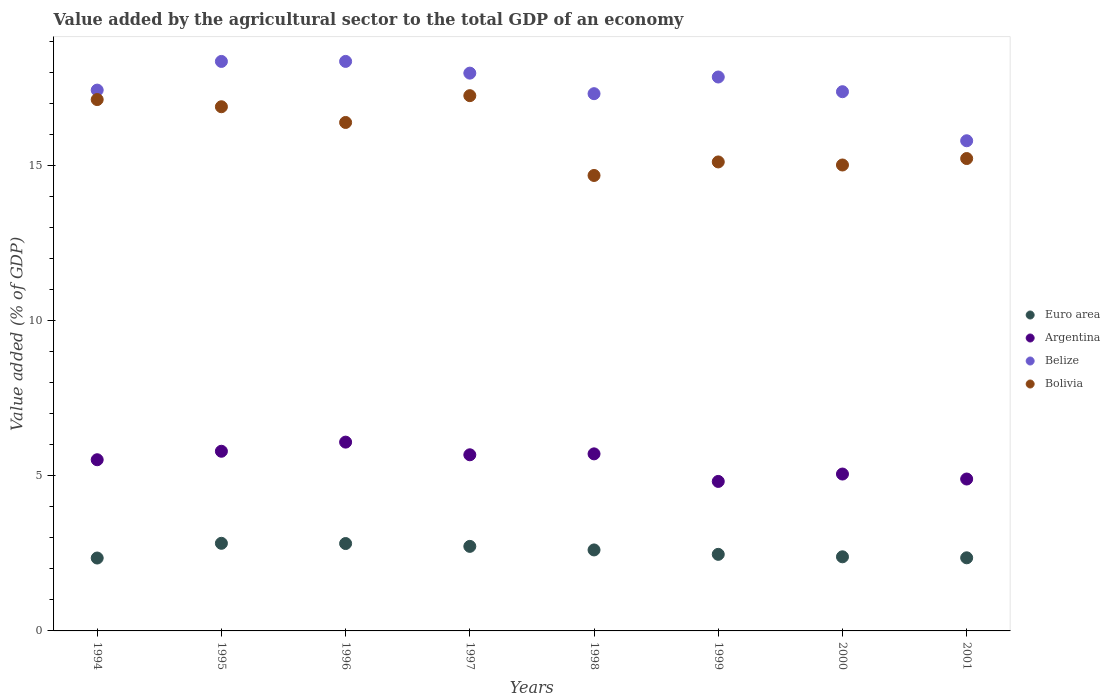How many different coloured dotlines are there?
Your answer should be very brief. 4. What is the value added by the agricultural sector to the total GDP in Argentina in 1994?
Your response must be concise. 5.51. Across all years, what is the maximum value added by the agricultural sector to the total GDP in Bolivia?
Keep it short and to the point. 17.24. Across all years, what is the minimum value added by the agricultural sector to the total GDP in Belize?
Make the answer very short. 15.79. In which year was the value added by the agricultural sector to the total GDP in Euro area minimum?
Offer a very short reply. 1994. What is the total value added by the agricultural sector to the total GDP in Euro area in the graph?
Provide a succinct answer. 20.53. What is the difference between the value added by the agricultural sector to the total GDP in Bolivia in 1994 and that in 2001?
Ensure brevity in your answer.  1.9. What is the difference between the value added by the agricultural sector to the total GDP in Euro area in 1995 and the value added by the agricultural sector to the total GDP in Bolivia in 1999?
Give a very brief answer. -12.28. What is the average value added by the agricultural sector to the total GDP in Argentina per year?
Your answer should be very brief. 5.44. In the year 1997, what is the difference between the value added by the agricultural sector to the total GDP in Euro area and value added by the agricultural sector to the total GDP in Belize?
Make the answer very short. -15.24. What is the ratio of the value added by the agricultural sector to the total GDP in Euro area in 1995 to that in 2000?
Your answer should be very brief. 1.18. Is the value added by the agricultural sector to the total GDP in Belize in 1997 less than that in 1999?
Keep it short and to the point. No. What is the difference between the highest and the second highest value added by the agricultural sector to the total GDP in Euro area?
Your response must be concise. 0.01. What is the difference between the highest and the lowest value added by the agricultural sector to the total GDP in Euro area?
Offer a terse response. 0.47. In how many years, is the value added by the agricultural sector to the total GDP in Bolivia greater than the average value added by the agricultural sector to the total GDP in Bolivia taken over all years?
Offer a very short reply. 4. Is it the case that in every year, the sum of the value added by the agricultural sector to the total GDP in Argentina and value added by the agricultural sector to the total GDP in Bolivia  is greater than the sum of value added by the agricultural sector to the total GDP in Belize and value added by the agricultural sector to the total GDP in Euro area?
Give a very brief answer. No. Is it the case that in every year, the sum of the value added by the agricultural sector to the total GDP in Belize and value added by the agricultural sector to the total GDP in Argentina  is greater than the value added by the agricultural sector to the total GDP in Euro area?
Keep it short and to the point. Yes. Is the value added by the agricultural sector to the total GDP in Euro area strictly greater than the value added by the agricultural sector to the total GDP in Argentina over the years?
Your answer should be compact. No. Is the value added by the agricultural sector to the total GDP in Bolivia strictly less than the value added by the agricultural sector to the total GDP in Euro area over the years?
Offer a terse response. No. How many dotlines are there?
Your response must be concise. 4. Are the values on the major ticks of Y-axis written in scientific E-notation?
Provide a succinct answer. No. Does the graph contain any zero values?
Offer a very short reply. No. Does the graph contain grids?
Give a very brief answer. No. How are the legend labels stacked?
Your answer should be very brief. Vertical. What is the title of the graph?
Offer a terse response. Value added by the agricultural sector to the total GDP of an economy. Does "Syrian Arab Republic" appear as one of the legend labels in the graph?
Keep it short and to the point. No. What is the label or title of the Y-axis?
Your answer should be very brief. Value added (% of GDP). What is the Value added (% of GDP) in Euro area in 1994?
Give a very brief answer. 2.35. What is the Value added (% of GDP) of Argentina in 1994?
Offer a very short reply. 5.51. What is the Value added (% of GDP) in Belize in 1994?
Provide a short and direct response. 17.42. What is the Value added (% of GDP) of Bolivia in 1994?
Offer a terse response. 17.11. What is the Value added (% of GDP) of Euro area in 1995?
Offer a very short reply. 2.82. What is the Value added (% of GDP) of Argentina in 1995?
Your answer should be very brief. 5.79. What is the Value added (% of GDP) in Belize in 1995?
Offer a terse response. 18.34. What is the Value added (% of GDP) of Bolivia in 1995?
Ensure brevity in your answer.  16.88. What is the Value added (% of GDP) in Euro area in 1996?
Ensure brevity in your answer.  2.81. What is the Value added (% of GDP) in Argentina in 1996?
Make the answer very short. 6.08. What is the Value added (% of GDP) of Belize in 1996?
Ensure brevity in your answer.  18.34. What is the Value added (% of GDP) in Bolivia in 1996?
Provide a short and direct response. 16.38. What is the Value added (% of GDP) of Euro area in 1997?
Your answer should be compact. 2.72. What is the Value added (% of GDP) in Argentina in 1997?
Offer a very short reply. 5.67. What is the Value added (% of GDP) of Belize in 1997?
Give a very brief answer. 17.97. What is the Value added (% of GDP) of Bolivia in 1997?
Provide a succinct answer. 17.24. What is the Value added (% of GDP) of Euro area in 1998?
Your answer should be compact. 2.61. What is the Value added (% of GDP) of Argentina in 1998?
Your answer should be compact. 5.7. What is the Value added (% of GDP) in Belize in 1998?
Make the answer very short. 17.3. What is the Value added (% of GDP) of Bolivia in 1998?
Make the answer very short. 14.67. What is the Value added (% of GDP) of Euro area in 1999?
Your answer should be compact. 2.47. What is the Value added (% of GDP) in Argentina in 1999?
Provide a short and direct response. 4.82. What is the Value added (% of GDP) in Belize in 1999?
Keep it short and to the point. 17.84. What is the Value added (% of GDP) of Bolivia in 1999?
Offer a very short reply. 15.11. What is the Value added (% of GDP) of Euro area in 2000?
Your answer should be compact. 2.39. What is the Value added (% of GDP) of Argentina in 2000?
Make the answer very short. 5.05. What is the Value added (% of GDP) of Belize in 2000?
Make the answer very short. 17.37. What is the Value added (% of GDP) in Bolivia in 2000?
Your response must be concise. 15.01. What is the Value added (% of GDP) of Euro area in 2001?
Your response must be concise. 2.36. What is the Value added (% of GDP) of Argentina in 2001?
Your answer should be very brief. 4.89. What is the Value added (% of GDP) in Belize in 2001?
Offer a terse response. 15.79. What is the Value added (% of GDP) of Bolivia in 2001?
Provide a short and direct response. 15.22. Across all years, what is the maximum Value added (% of GDP) of Euro area?
Offer a very short reply. 2.82. Across all years, what is the maximum Value added (% of GDP) of Argentina?
Your answer should be compact. 6.08. Across all years, what is the maximum Value added (% of GDP) of Belize?
Your answer should be compact. 18.34. Across all years, what is the maximum Value added (% of GDP) of Bolivia?
Provide a short and direct response. 17.24. Across all years, what is the minimum Value added (% of GDP) in Euro area?
Make the answer very short. 2.35. Across all years, what is the minimum Value added (% of GDP) in Argentina?
Make the answer very short. 4.82. Across all years, what is the minimum Value added (% of GDP) in Belize?
Ensure brevity in your answer.  15.79. Across all years, what is the minimum Value added (% of GDP) of Bolivia?
Provide a short and direct response. 14.67. What is the total Value added (% of GDP) in Euro area in the graph?
Provide a succinct answer. 20.53. What is the total Value added (% of GDP) in Argentina in the graph?
Provide a succinct answer. 43.52. What is the total Value added (% of GDP) of Belize in the graph?
Provide a succinct answer. 140.38. What is the total Value added (% of GDP) in Bolivia in the graph?
Offer a terse response. 127.62. What is the difference between the Value added (% of GDP) of Euro area in 1994 and that in 1995?
Offer a very short reply. -0.47. What is the difference between the Value added (% of GDP) in Argentina in 1994 and that in 1995?
Your answer should be very brief. -0.27. What is the difference between the Value added (% of GDP) of Belize in 1994 and that in 1995?
Give a very brief answer. -0.92. What is the difference between the Value added (% of GDP) of Bolivia in 1994 and that in 1995?
Ensure brevity in your answer.  0.23. What is the difference between the Value added (% of GDP) of Euro area in 1994 and that in 1996?
Keep it short and to the point. -0.47. What is the difference between the Value added (% of GDP) of Argentina in 1994 and that in 1996?
Your answer should be very brief. -0.57. What is the difference between the Value added (% of GDP) in Belize in 1994 and that in 1996?
Provide a short and direct response. -0.92. What is the difference between the Value added (% of GDP) of Bolivia in 1994 and that in 1996?
Give a very brief answer. 0.74. What is the difference between the Value added (% of GDP) of Euro area in 1994 and that in 1997?
Make the answer very short. -0.38. What is the difference between the Value added (% of GDP) of Argentina in 1994 and that in 1997?
Ensure brevity in your answer.  -0.16. What is the difference between the Value added (% of GDP) in Belize in 1994 and that in 1997?
Provide a succinct answer. -0.55. What is the difference between the Value added (% of GDP) of Bolivia in 1994 and that in 1997?
Provide a succinct answer. -0.13. What is the difference between the Value added (% of GDP) of Euro area in 1994 and that in 1998?
Ensure brevity in your answer.  -0.26. What is the difference between the Value added (% of GDP) in Argentina in 1994 and that in 1998?
Provide a succinct answer. -0.19. What is the difference between the Value added (% of GDP) in Belize in 1994 and that in 1998?
Offer a very short reply. 0.12. What is the difference between the Value added (% of GDP) in Bolivia in 1994 and that in 1998?
Keep it short and to the point. 2.44. What is the difference between the Value added (% of GDP) in Euro area in 1994 and that in 1999?
Your answer should be compact. -0.12. What is the difference between the Value added (% of GDP) of Argentina in 1994 and that in 1999?
Your answer should be compact. 0.7. What is the difference between the Value added (% of GDP) in Belize in 1994 and that in 1999?
Provide a short and direct response. -0.42. What is the difference between the Value added (% of GDP) in Bolivia in 1994 and that in 1999?
Your response must be concise. 2.01. What is the difference between the Value added (% of GDP) of Euro area in 1994 and that in 2000?
Make the answer very short. -0.04. What is the difference between the Value added (% of GDP) in Argentina in 1994 and that in 2000?
Your answer should be compact. 0.46. What is the difference between the Value added (% of GDP) in Belize in 1994 and that in 2000?
Your response must be concise. 0.05. What is the difference between the Value added (% of GDP) in Bolivia in 1994 and that in 2000?
Provide a succinct answer. 2.11. What is the difference between the Value added (% of GDP) in Euro area in 1994 and that in 2001?
Keep it short and to the point. -0.01. What is the difference between the Value added (% of GDP) of Argentina in 1994 and that in 2001?
Make the answer very short. 0.62. What is the difference between the Value added (% of GDP) of Belize in 1994 and that in 2001?
Your answer should be very brief. 1.63. What is the difference between the Value added (% of GDP) of Bolivia in 1994 and that in 2001?
Your answer should be compact. 1.9. What is the difference between the Value added (% of GDP) of Euro area in 1995 and that in 1996?
Keep it short and to the point. 0.01. What is the difference between the Value added (% of GDP) in Argentina in 1995 and that in 1996?
Offer a terse response. -0.29. What is the difference between the Value added (% of GDP) of Belize in 1995 and that in 1996?
Provide a short and direct response. -0. What is the difference between the Value added (% of GDP) in Bolivia in 1995 and that in 1996?
Provide a short and direct response. 0.51. What is the difference between the Value added (% of GDP) of Euro area in 1995 and that in 1997?
Your answer should be very brief. 0.1. What is the difference between the Value added (% of GDP) in Argentina in 1995 and that in 1997?
Make the answer very short. 0.11. What is the difference between the Value added (% of GDP) of Belize in 1995 and that in 1997?
Offer a very short reply. 0.38. What is the difference between the Value added (% of GDP) in Bolivia in 1995 and that in 1997?
Offer a terse response. -0.36. What is the difference between the Value added (% of GDP) in Euro area in 1995 and that in 1998?
Provide a succinct answer. 0.21. What is the difference between the Value added (% of GDP) in Argentina in 1995 and that in 1998?
Provide a short and direct response. 0.08. What is the difference between the Value added (% of GDP) of Belize in 1995 and that in 1998?
Provide a short and direct response. 1.04. What is the difference between the Value added (% of GDP) of Bolivia in 1995 and that in 1998?
Your answer should be very brief. 2.21. What is the difference between the Value added (% of GDP) of Euro area in 1995 and that in 1999?
Provide a short and direct response. 0.36. What is the difference between the Value added (% of GDP) of Argentina in 1995 and that in 1999?
Your answer should be very brief. 0.97. What is the difference between the Value added (% of GDP) of Belize in 1995 and that in 1999?
Make the answer very short. 0.5. What is the difference between the Value added (% of GDP) in Bolivia in 1995 and that in 1999?
Give a very brief answer. 1.78. What is the difference between the Value added (% of GDP) in Euro area in 1995 and that in 2000?
Your answer should be very brief. 0.43. What is the difference between the Value added (% of GDP) of Argentina in 1995 and that in 2000?
Make the answer very short. 0.73. What is the difference between the Value added (% of GDP) of Belize in 1995 and that in 2000?
Offer a very short reply. 0.98. What is the difference between the Value added (% of GDP) of Bolivia in 1995 and that in 2000?
Your answer should be very brief. 1.88. What is the difference between the Value added (% of GDP) of Euro area in 1995 and that in 2001?
Offer a very short reply. 0.47. What is the difference between the Value added (% of GDP) in Argentina in 1995 and that in 2001?
Offer a terse response. 0.89. What is the difference between the Value added (% of GDP) in Belize in 1995 and that in 2001?
Your response must be concise. 2.56. What is the difference between the Value added (% of GDP) in Bolivia in 1995 and that in 2001?
Provide a succinct answer. 1.67. What is the difference between the Value added (% of GDP) in Euro area in 1996 and that in 1997?
Your response must be concise. 0.09. What is the difference between the Value added (% of GDP) of Argentina in 1996 and that in 1997?
Give a very brief answer. 0.41. What is the difference between the Value added (% of GDP) of Belize in 1996 and that in 1997?
Provide a short and direct response. 0.38. What is the difference between the Value added (% of GDP) in Bolivia in 1996 and that in 1997?
Keep it short and to the point. -0.86. What is the difference between the Value added (% of GDP) in Euro area in 1996 and that in 1998?
Offer a very short reply. 0.21. What is the difference between the Value added (% of GDP) in Argentina in 1996 and that in 1998?
Make the answer very short. 0.38. What is the difference between the Value added (% of GDP) in Belize in 1996 and that in 1998?
Your answer should be compact. 1.04. What is the difference between the Value added (% of GDP) in Bolivia in 1996 and that in 1998?
Your answer should be compact. 1.71. What is the difference between the Value added (% of GDP) in Euro area in 1996 and that in 1999?
Keep it short and to the point. 0.35. What is the difference between the Value added (% of GDP) of Argentina in 1996 and that in 1999?
Your answer should be compact. 1.27. What is the difference between the Value added (% of GDP) of Belize in 1996 and that in 1999?
Ensure brevity in your answer.  0.5. What is the difference between the Value added (% of GDP) in Bolivia in 1996 and that in 1999?
Your answer should be compact. 1.27. What is the difference between the Value added (% of GDP) of Euro area in 1996 and that in 2000?
Keep it short and to the point. 0.43. What is the difference between the Value added (% of GDP) of Argentina in 1996 and that in 2000?
Give a very brief answer. 1.03. What is the difference between the Value added (% of GDP) of Bolivia in 1996 and that in 2000?
Your answer should be compact. 1.37. What is the difference between the Value added (% of GDP) in Euro area in 1996 and that in 2001?
Your answer should be very brief. 0.46. What is the difference between the Value added (% of GDP) of Argentina in 1996 and that in 2001?
Keep it short and to the point. 1.19. What is the difference between the Value added (% of GDP) of Belize in 1996 and that in 2001?
Offer a terse response. 2.56. What is the difference between the Value added (% of GDP) in Bolivia in 1996 and that in 2001?
Ensure brevity in your answer.  1.16. What is the difference between the Value added (% of GDP) in Euro area in 1997 and that in 1998?
Your response must be concise. 0.11. What is the difference between the Value added (% of GDP) of Argentina in 1997 and that in 1998?
Ensure brevity in your answer.  -0.03. What is the difference between the Value added (% of GDP) of Belize in 1997 and that in 1998?
Make the answer very short. 0.66. What is the difference between the Value added (% of GDP) in Bolivia in 1997 and that in 1998?
Provide a succinct answer. 2.57. What is the difference between the Value added (% of GDP) of Euro area in 1997 and that in 1999?
Offer a very short reply. 0.26. What is the difference between the Value added (% of GDP) in Argentina in 1997 and that in 1999?
Ensure brevity in your answer.  0.86. What is the difference between the Value added (% of GDP) of Belize in 1997 and that in 1999?
Provide a short and direct response. 0.12. What is the difference between the Value added (% of GDP) in Bolivia in 1997 and that in 1999?
Make the answer very short. 2.13. What is the difference between the Value added (% of GDP) in Euro area in 1997 and that in 2000?
Keep it short and to the point. 0.34. What is the difference between the Value added (% of GDP) of Argentina in 1997 and that in 2000?
Provide a succinct answer. 0.62. What is the difference between the Value added (% of GDP) in Belize in 1997 and that in 2000?
Offer a terse response. 0.6. What is the difference between the Value added (% of GDP) of Bolivia in 1997 and that in 2000?
Make the answer very short. 2.23. What is the difference between the Value added (% of GDP) in Euro area in 1997 and that in 2001?
Make the answer very short. 0.37. What is the difference between the Value added (% of GDP) in Argentina in 1997 and that in 2001?
Your response must be concise. 0.78. What is the difference between the Value added (% of GDP) in Belize in 1997 and that in 2001?
Offer a terse response. 2.18. What is the difference between the Value added (% of GDP) of Bolivia in 1997 and that in 2001?
Provide a succinct answer. 2.03. What is the difference between the Value added (% of GDP) of Euro area in 1998 and that in 1999?
Your response must be concise. 0.14. What is the difference between the Value added (% of GDP) of Argentina in 1998 and that in 1999?
Offer a terse response. 0.89. What is the difference between the Value added (% of GDP) of Belize in 1998 and that in 1999?
Provide a succinct answer. -0.54. What is the difference between the Value added (% of GDP) of Bolivia in 1998 and that in 1999?
Ensure brevity in your answer.  -0.44. What is the difference between the Value added (% of GDP) in Euro area in 1998 and that in 2000?
Your response must be concise. 0.22. What is the difference between the Value added (% of GDP) of Argentina in 1998 and that in 2000?
Your answer should be compact. 0.65. What is the difference between the Value added (% of GDP) of Belize in 1998 and that in 2000?
Your answer should be compact. -0.06. What is the difference between the Value added (% of GDP) in Bolivia in 1998 and that in 2000?
Provide a short and direct response. -0.34. What is the difference between the Value added (% of GDP) in Euro area in 1998 and that in 2001?
Give a very brief answer. 0.25. What is the difference between the Value added (% of GDP) of Argentina in 1998 and that in 2001?
Give a very brief answer. 0.81. What is the difference between the Value added (% of GDP) of Belize in 1998 and that in 2001?
Provide a short and direct response. 1.52. What is the difference between the Value added (% of GDP) of Bolivia in 1998 and that in 2001?
Offer a very short reply. -0.55. What is the difference between the Value added (% of GDP) of Euro area in 1999 and that in 2000?
Ensure brevity in your answer.  0.08. What is the difference between the Value added (% of GDP) in Argentina in 1999 and that in 2000?
Give a very brief answer. -0.24. What is the difference between the Value added (% of GDP) in Belize in 1999 and that in 2000?
Your answer should be compact. 0.47. What is the difference between the Value added (% of GDP) in Bolivia in 1999 and that in 2000?
Give a very brief answer. 0.1. What is the difference between the Value added (% of GDP) in Euro area in 1999 and that in 2001?
Your answer should be very brief. 0.11. What is the difference between the Value added (% of GDP) of Argentina in 1999 and that in 2001?
Your answer should be very brief. -0.08. What is the difference between the Value added (% of GDP) of Belize in 1999 and that in 2001?
Offer a terse response. 2.05. What is the difference between the Value added (% of GDP) in Bolivia in 1999 and that in 2001?
Give a very brief answer. -0.11. What is the difference between the Value added (% of GDP) of Euro area in 2000 and that in 2001?
Give a very brief answer. 0.03. What is the difference between the Value added (% of GDP) of Argentina in 2000 and that in 2001?
Provide a succinct answer. 0.16. What is the difference between the Value added (% of GDP) in Belize in 2000 and that in 2001?
Give a very brief answer. 1.58. What is the difference between the Value added (% of GDP) in Bolivia in 2000 and that in 2001?
Your response must be concise. -0.21. What is the difference between the Value added (% of GDP) of Euro area in 1994 and the Value added (% of GDP) of Argentina in 1995?
Keep it short and to the point. -3.44. What is the difference between the Value added (% of GDP) of Euro area in 1994 and the Value added (% of GDP) of Belize in 1995?
Provide a short and direct response. -16. What is the difference between the Value added (% of GDP) in Euro area in 1994 and the Value added (% of GDP) in Bolivia in 1995?
Make the answer very short. -14.54. What is the difference between the Value added (% of GDP) in Argentina in 1994 and the Value added (% of GDP) in Belize in 1995?
Keep it short and to the point. -12.83. What is the difference between the Value added (% of GDP) of Argentina in 1994 and the Value added (% of GDP) of Bolivia in 1995?
Your response must be concise. -11.37. What is the difference between the Value added (% of GDP) in Belize in 1994 and the Value added (% of GDP) in Bolivia in 1995?
Make the answer very short. 0.54. What is the difference between the Value added (% of GDP) in Euro area in 1994 and the Value added (% of GDP) in Argentina in 1996?
Your answer should be compact. -3.73. What is the difference between the Value added (% of GDP) in Euro area in 1994 and the Value added (% of GDP) in Belize in 1996?
Offer a very short reply. -16. What is the difference between the Value added (% of GDP) in Euro area in 1994 and the Value added (% of GDP) in Bolivia in 1996?
Your response must be concise. -14.03. What is the difference between the Value added (% of GDP) of Argentina in 1994 and the Value added (% of GDP) of Belize in 1996?
Give a very brief answer. -12.83. What is the difference between the Value added (% of GDP) of Argentina in 1994 and the Value added (% of GDP) of Bolivia in 1996?
Offer a very short reply. -10.86. What is the difference between the Value added (% of GDP) of Belize in 1994 and the Value added (% of GDP) of Bolivia in 1996?
Give a very brief answer. 1.04. What is the difference between the Value added (% of GDP) in Euro area in 1994 and the Value added (% of GDP) in Argentina in 1997?
Provide a succinct answer. -3.33. What is the difference between the Value added (% of GDP) in Euro area in 1994 and the Value added (% of GDP) in Belize in 1997?
Provide a succinct answer. -15.62. What is the difference between the Value added (% of GDP) of Euro area in 1994 and the Value added (% of GDP) of Bolivia in 1997?
Ensure brevity in your answer.  -14.89. What is the difference between the Value added (% of GDP) in Argentina in 1994 and the Value added (% of GDP) in Belize in 1997?
Your answer should be very brief. -12.45. What is the difference between the Value added (% of GDP) in Argentina in 1994 and the Value added (% of GDP) in Bolivia in 1997?
Provide a succinct answer. -11.73. What is the difference between the Value added (% of GDP) of Belize in 1994 and the Value added (% of GDP) of Bolivia in 1997?
Your response must be concise. 0.18. What is the difference between the Value added (% of GDP) of Euro area in 1994 and the Value added (% of GDP) of Argentina in 1998?
Ensure brevity in your answer.  -3.35. What is the difference between the Value added (% of GDP) of Euro area in 1994 and the Value added (% of GDP) of Belize in 1998?
Provide a succinct answer. -14.96. What is the difference between the Value added (% of GDP) in Euro area in 1994 and the Value added (% of GDP) in Bolivia in 1998?
Provide a succinct answer. -12.32. What is the difference between the Value added (% of GDP) of Argentina in 1994 and the Value added (% of GDP) of Belize in 1998?
Make the answer very short. -11.79. What is the difference between the Value added (% of GDP) of Argentina in 1994 and the Value added (% of GDP) of Bolivia in 1998?
Your answer should be compact. -9.16. What is the difference between the Value added (% of GDP) of Belize in 1994 and the Value added (% of GDP) of Bolivia in 1998?
Provide a succinct answer. 2.75. What is the difference between the Value added (% of GDP) of Euro area in 1994 and the Value added (% of GDP) of Argentina in 1999?
Provide a short and direct response. -2.47. What is the difference between the Value added (% of GDP) in Euro area in 1994 and the Value added (% of GDP) in Belize in 1999?
Offer a very short reply. -15.49. What is the difference between the Value added (% of GDP) in Euro area in 1994 and the Value added (% of GDP) in Bolivia in 1999?
Ensure brevity in your answer.  -12.76. What is the difference between the Value added (% of GDP) in Argentina in 1994 and the Value added (% of GDP) in Belize in 1999?
Offer a terse response. -12.33. What is the difference between the Value added (% of GDP) of Argentina in 1994 and the Value added (% of GDP) of Bolivia in 1999?
Offer a very short reply. -9.59. What is the difference between the Value added (% of GDP) in Belize in 1994 and the Value added (% of GDP) in Bolivia in 1999?
Provide a short and direct response. 2.31. What is the difference between the Value added (% of GDP) of Euro area in 1994 and the Value added (% of GDP) of Argentina in 2000?
Offer a terse response. -2.71. What is the difference between the Value added (% of GDP) of Euro area in 1994 and the Value added (% of GDP) of Belize in 2000?
Give a very brief answer. -15.02. What is the difference between the Value added (% of GDP) in Euro area in 1994 and the Value added (% of GDP) in Bolivia in 2000?
Provide a short and direct response. -12.66. What is the difference between the Value added (% of GDP) in Argentina in 1994 and the Value added (% of GDP) in Belize in 2000?
Give a very brief answer. -11.85. What is the difference between the Value added (% of GDP) of Argentina in 1994 and the Value added (% of GDP) of Bolivia in 2000?
Offer a very short reply. -9.49. What is the difference between the Value added (% of GDP) of Belize in 1994 and the Value added (% of GDP) of Bolivia in 2000?
Offer a terse response. 2.41. What is the difference between the Value added (% of GDP) in Euro area in 1994 and the Value added (% of GDP) in Argentina in 2001?
Ensure brevity in your answer.  -2.54. What is the difference between the Value added (% of GDP) of Euro area in 1994 and the Value added (% of GDP) of Belize in 2001?
Make the answer very short. -13.44. What is the difference between the Value added (% of GDP) of Euro area in 1994 and the Value added (% of GDP) of Bolivia in 2001?
Provide a succinct answer. -12.87. What is the difference between the Value added (% of GDP) of Argentina in 1994 and the Value added (% of GDP) of Belize in 2001?
Offer a terse response. -10.27. What is the difference between the Value added (% of GDP) of Argentina in 1994 and the Value added (% of GDP) of Bolivia in 2001?
Your response must be concise. -9.7. What is the difference between the Value added (% of GDP) in Belize in 1994 and the Value added (% of GDP) in Bolivia in 2001?
Your answer should be very brief. 2.2. What is the difference between the Value added (% of GDP) of Euro area in 1995 and the Value added (% of GDP) of Argentina in 1996?
Give a very brief answer. -3.26. What is the difference between the Value added (% of GDP) of Euro area in 1995 and the Value added (% of GDP) of Belize in 1996?
Provide a succinct answer. -15.52. What is the difference between the Value added (% of GDP) of Euro area in 1995 and the Value added (% of GDP) of Bolivia in 1996?
Give a very brief answer. -13.56. What is the difference between the Value added (% of GDP) in Argentina in 1995 and the Value added (% of GDP) in Belize in 1996?
Offer a very short reply. -12.56. What is the difference between the Value added (% of GDP) of Argentina in 1995 and the Value added (% of GDP) of Bolivia in 1996?
Offer a terse response. -10.59. What is the difference between the Value added (% of GDP) in Belize in 1995 and the Value added (% of GDP) in Bolivia in 1996?
Keep it short and to the point. 1.97. What is the difference between the Value added (% of GDP) of Euro area in 1995 and the Value added (% of GDP) of Argentina in 1997?
Ensure brevity in your answer.  -2.85. What is the difference between the Value added (% of GDP) of Euro area in 1995 and the Value added (% of GDP) of Belize in 1997?
Ensure brevity in your answer.  -15.14. What is the difference between the Value added (% of GDP) in Euro area in 1995 and the Value added (% of GDP) in Bolivia in 1997?
Provide a short and direct response. -14.42. What is the difference between the Value added (% of GDP) in Argentina in 1995 and the Value added (% of GDP) in Belize in 1997?
Your answer should be very brief. -12.18. What is the difference between the Value added (% of GDP) of Argentina in 1995 and the Value added (% of GDP) of Bolivia in 1997?
Provide a short and direct response. -11.45. What is the difference between the Value added (% of GDP) of Belize in 1995 and the Value added (% of GDP) of Bolivia in 1997?
Provide a short and direct response. 1.1. What is the difference between the Value added (% of GDP) in Euro area in 1995 and the Value added (% of GDP) in Argentina in 1998?
Ensure brevity in your answer.  -2.88. What is the difference between the Value added (% of GDP) in Euro area in 1995 and the Value added (% of GDP) in Belize in 1998?
Your answer should be compact. -14.48. What is the difference between the Value added (% of GDP) of Euro area in 1995 and the Value added (% of GDP) of Bolivia in 1998?
Give a very brief answer. -11.85. What is the difference between the Value added (% of GDP) in Argentina in 1995 and the Value added (% of GDP) in Belize in 1998?
Give a very brief answer. -11.52. What is the difference between the Value added (% of GDP) of Argentina in 1995 and the Value added (% of GDP) of Bolivia in 1998?
Offer a terse response. -8.88. What is the difference between the Value added (% of GDP) of Belize in 1995 and the Value added (% of GDP) of Bolivia in 1998?
Ensure brevity in your answer.  3.67. What is the difference between the Value added (% of GDP) in Euro area in 1995 and the Value added (% of GDP) in Argentina in 1999?
Make the answer very short. -1.99. What is the difference between the Value added (% of GDP) of Euro area in 1995 and the Value added (% of GDP) of Belize in 1999?
Keep it short and to the point. -15.02. What is the difference between the Value added (% of GDP) in Euro area in 1995 and the Value added (% of GDP) in Bolivia in 1999?
Give a very brief answer. -12.28. What is the difference between the Value added (% of GDP) in Argentina in 1995 and the Value added (% of GDP) in Belize in 1999?
Provide a short and direct response. -12.05. What is the difference between the Value added (% of GDP) of Argentina in 1995 and the Value added (% of GDP) of Bolivia in 1999?
Offer a very short reply. -9.32. What is the difference between the Value added (% of GDP) in Belize in 1995 and the Value added (% of GDP) in Bolivia in 1999?
Keep it short and to the point. 3.24. What is the difference between the Value added (% of GDP) of Euro area in 1995 and the Value added (% of GDP) of Argentina in 2000?
Keep it short and to the point. -2.23. What is the difference between the Value added (% of GDP) in Euro area in 1995 and the Value added (% of GDP) in Belize in 2000?
Make the answer very short. -14.55. What is the difference between the Value added (% of GDP) of Euro area in 1995 and the Value added (% of GDP) of Bolivia in 2000?
Offer a very short reply. -12.19. What is the difference between the Value added (% of GDP) of Argentina in 1995 and the Value added (% of GDP) of Belize in 2000?
Provide a succinct answer. -11.58. What is the difference between the Value added (% of GDP) in Argentina in 1995 and the Value added (% of GDP) in Bolivia in 2000?
Ensure brevity in your answer.  -9.22. What is the difference between the Value added (% of GDP) in Belize in 1995 and the Value added (% of GDP) in Bolivia in 2000?
Keep it short and to the point. 3.34. What is the difference between the Value added (% of GDP) in Euro area in 1995 and the Value added (% of GDP) in Argentina in 2001?
Give a very brief answer. -2.07. What is the difference between the Value added (% of GDP) of Euro area in 1995 and the Value added (% of GDP) of Belize in 2001?
Offer a very short reply. -12.97. What is the difference between the Value added (% of GDP) in Euro area in 1995 and the Value added (% of GDP) in Bolivia in 2001?
Give a very brief answer. -12.39. What is the difference between the Value added (% of GDP) of Argentina in 1995 and the Value added (% of GDP) of Belize in 2001?
Your answer should be compact. -10. What is the difference between the Value added (% of GDP) in Argentina in 1995 and the Value added (% of GDP) in Bolivia in 2001?
Provide a succinct answer. -9.43. What is the difference between the Value added (% of GDP) of Belize in 1995 and the Value added (% of GDP) of Bolivia in 2001?
Your answer should be very brief. 3.13. What is the difference between the Value added (% of GDP) of Euro area in 1996 and the Value added (% of GDP) of Argentina in 1997?
Offer a terse response. -2.86. What is the difference between the Value added (% of GDP) in Euro area in 1996 and the Value added (% of GDP) in Belize in 1997?
Give a very brief answer. -15.15. What is the difference between the Value added (% of GDP) in Euro area in 1996 and the Value added (% of GDP) in Bolivia in 1997?
Make the answer very short. -14.43. What is the difference between the Value added (% of GDP) of Argentina in 1996 and the Value added (% of GDP) of Belize in 1997?
Provide a succinct answer. -11.89. What is the difference between the Value added (% of GDP) of Argentina in 1996 and the Value added (% of GDP) of Bolivia in 1997?
Your answer should be very brief. -11.16. What is the difference between the Value added (% of GDP) of Belize in 1996 and the Value added (% of GDP) of Bolivia in 1997?
Make the answer very short. 1.1. What is the difference between the Value added (% of GDP) of Euro area in 1996 and the Value added (% of GDP) of Argentina in 1998?
Your response must be concise. -2.89. What is the difference between the Value added (% of GDP) in Euro area in 1996 and the Value added (% of GDP) in Belize in 1998?
Provide a succinct answer. -14.49. What is the difference between the Value added (% of GDP) of Euro area in 1996 and the Value added (% of GDP) of Bolivia in 1998?
Offer a very short reply. -11.86. What is the difference between the Value added (% of GDP) of Argentina in 1996 and the Value added (% of GDP) of Belize in 1998?
Offer a terse response. -11.22. What is the difference between the Value added (% of GDP) in Argentina in 1996 and the Value added (% of GDP) in Bolivia in 1998?
Make the answer very short. -8.59. What is the difference between the Value added (% of GDP) of Belize in 1996 and the Value added (% of GDP) of Bolivia in 1998?
Your answer should be compact. 3.67. What is the difference between the Value added (% of GDP) in Euro area in 1996 and the Value added (% of GDP) in Argentina in 1999?
Offer a terse response. -2. What is the difference between the Value added (% of GDP) of Euro area in 1996 and the Value added (% of GDP) of Belize in 1999?
Your answer should be very brief. -15.03. What is the difference between the Value added (% of GDP) of Euro area in 1996 and the Value added (% of GDP) of Bolivia in 1999?
Your answer should be very brief. -12.29. What is the difference between the Value added (% of GDP) of Argentina in 1996 and the Value added (% of GDP) of Belize in 1999?
Keep it short and to the point. -11.76. What is the difference between the Value added (% of GDP) in Argentina in 1996 and the Value added (% of GDP) in Bolivia in 1999?
Make the answer very short. -9.02. What is the difference between the Value added (% of GDP) in Belize in 1996 and the Value added (% of GDP) in Bolivia in 1999?
Provide a succinct answer. 3.24. What is the difference between the Value added (% of GDP) in Euro area in 1996 and the Value added (% of GDP) in Argentina in 2000?
Keep it short and to the point. -2.24. What is the difference between the Value added (% of GDP) in Euro area in 1996 and the Value added (% of GDP) in Belize in 2000?
Give a very brief answer. -14.55. What is the difference between the Value added (% of GDP) in Euro area in 1996 and the Value added (% of GDP) in Bolivia in 2000?
Keep it short and to the point. -12.19. What is the difference between the Value added (% of GDP) in Argentina in 1996 and the Value added (% of GDP) in Belize in 2000?
Keep it short and to the point. -11.29. What is the difference between the Value added (% of GDP) of Argentina in 1996 and the Value added (% of GDP) of Bolivia in 2000?
Give a very brief answer. -8.93. What is the difference between the Value added (% of GDP) in Belize in 1996 and the Value added (% of GDP) in Bolivia in 2000?
Offer a terse response. 3.34. What is the difference between the Value added (% of GDP) in Euro area in 1996 and the Value added (% of GDP) in Argentina in 2001?
Offer a terse response. -2.08. What is the difference between the Value added (% of GDP) of Euro area in 1996 and the Value added (% of GDP) of Belize in 2001?
Offer a very short reply. -12.97. What is the difference between the Value added (% of GDP) in Euro area in 1996 and the Value added (% of GDP) in Bolivia in 2001?
Keep it short and to the point. -12.4. What is the difference between the Value added (% of GDP) of Argentina in 1996 and the Value added (% of GDP) of Belize in 2001?
Ensure brevity in your answer.  -9.71. What is the difference between the Value added (% of GDP) in Argentina in 1996 and the Value added (% of GDP) in Bolivia in 2001?
Keep it short and to the point. -9.13. What is the difference between the Value added (% of GDP) in Belize in 1996 and the Value added (% of GDP) in Bolivia in 2001?
Offer a very short reply. 3.13. What is the difference between the Value added (% of GDP) in Euro area in 1997 and the Value added (% of GDP) in Argentina in 1998?
Keep it short and to the point. -2.98. What is the difference between the Value added (% of GDP) in Euro area in 1997 and the Value added (% of GDP) in Belize in 1998?
Ensure brevity in your answer.  -14.58. What is the difference between the Value added (% of GDP) of Euro area in 1997 and the Value added (% of GDP) of Bolivia in 1998?
Keep it short and to the point. -11.95. What is the difference between the Value added (% of GDP) of Argentina in 1997 and the Value added (% of GDP) of Belize in 1998?
Your response must be concise. -11.63. What is the difference between the Value added (% of GDP) in Argentina in 1997 and the Value added (% of GDP) in Bolivia in 1998?
Make the answer very short. -9. What is the difference between the Value added (% of GDP) in Belize in 1997 and the Value added (% of GDP) in Bolivia in 1998?
Keep it short and to the point. 3.3. What is the difference between the Value added (% of GDP) of Euro area in 1997 and the Value added (% of GDP) of Argentina in 1999?
Make the answer very short. -2.09. What is the difference between the Value added (% of GDP) in Euro area in 1997 and the Value added (% of GDP) in Belize in 1999?
Make the answer very short. -15.12. What is the difference between the Value added (% of GDP) of Euro area in 1997 and the Value added (% of GDP) of Bolivia in 1999?
Your answer should be very brief. -12.38. What is the difference between the Value added (% of GDP) of Argentina in 1997 and the Value added (% of GDP) of Belize in 1999?
Ensure brevity in your answer.  -12.17. What is the difference between the Value added (% of GDP) of Argentina in 1997 and the Value added (% of GDP) of Bolivia in 1999?
Your answer should be compact. -9.43. What is the difference between the Value added (% of GDP) in Belize in 1997 and the Value added (% of GDP) in Bolivia in 1999?
Ensure brevity in your answer.  2.86. What is the difference between the Value added (% of GDP) in Euro area in 1997 and the Value added (% of GDP) in Argentina in 2000?
Make the answer very short. -2.33. What is the difference between the Value added (% of GDP) in Euro area in 1997 and the Value added (% of GDP) in Belize in 2000?
Your response must be concise. -14.64. What is the difference between the Value added (% of GDP) in Euro area in 1997 and the Value added (% of GDP) in Bolivia in 2000?
Give a very brief answer. -12.28. What is the difference between the Value added (% of GDP) of Argentina in 1997 and the Value added (% of GDP) of Belize in 2000?
Ensure brevity in your answer.  -11.69. What is the difference between the Value added (% of GDP) of Argentina in 1997 and the Value added (% of GDP) of Bolivia in 2000?
Give a very brief answer. -9.33. What is the difference between the Value added (% of GDP) in Belize in 1997 and the Value added (% of GDP) in Bolivia in 2000?
Offer a very short reply. 2.96. What is the difference between the Value added (% of GDP) in Euro area in 1997 and the Value added (% of GDP) in Argentina in 2001?
Give a very brief answer. -2.17. What is the difference between the Value added (% of GDP) in Euro area in 1997 and the Value added (% of GDP) in Belize in 2001?
Offer a terse response. -13.06. What is the difference between the Value added (% of GDP) of Euro area in 1997 and the Value added (% of GDP) of Bolivia in 2001?
Your answer should be very brief. -12.49. What is the difference between the Value added (% of GDP) of Argentina in 1997 and the Value added (% of GDP) of Belize in 2001?
Your response must be concise. -10.11. What is the difference between the Value added (% of GDP) of Argentina in 1997 and the Value added (% of GDP) of Bolivia in 2001?
Provide a succinct answer. -9.54. What is the difference between the Value added (% of GDP) of Belize in 1997 and the Value added (% of GDP) of Bolivia in 2001?
Ensure brevity in your answer.  2.75. What is the difference between the Value added (% of GDP) of Euro area in 1998 and the Value added (% of GDP) of Argentina in 1999?
Your answer should be compact. -2.21. What is the difference between the Value added (% of GDP) in Euro area in 1998 and the Value added (% of GDP) in Belize in 1999?
Make the answer very short. -15.23. What is the difference between the Value added (% of GDP) of Euro area in 1998 and the Value added (% of GDP) of Bolivia in 1999?
Your answer should be compact. -12.5. What is the difference between the Value added (% of GDP) in Argentina in 1998 and the Value added (% of GDP) in Belize in 1999?
Keep it short and to the point. -12.14. What is the difference between the Value added (% of GDP) in Argentina in 1998 and the Value added (% of GDP) in Bolivia in 1999?
Keep it short and to the point. -9.4. What is the difference between the Value added (% of GDP) in Belize in 1998 and the Value added (% of GDP) in Bolivia in 1999?
Give a very brief answer. 2.2. What is the difference between the Value added (% of GDP) of Euro area in 1998 and the Value added (% of GDP) of Argentina in 2000?
Provide a short and direct response. -2.44. What is the difference between the Value added (% of GDP) of Euro area in 1998 and the Value added (% of GDP) of Belize in 2000?
Your answer should be compact. -14.76. What is the difference between the Value added (% of GDP) of Euro area in 1998 and the Value added (% of GDP) of Bolivia in 2000?
Your answer should be very brief. -12.4. What is the difference between the Value added (% of GDP) of Argentina in 1998 and the Value added (% of GDP) of Belize in 2000?
Give a very brief answer. -11.67. What is the difference between the Value added (% of GDP) of Argentina in 1998 and the Value added (% of GDP) of Bolivia in 2000?
Offer a terse response. -9.3. What is the difference between the Value added (% of GDP) in Belize in 1998 and the Value added (% of GDP) in Bolivia in 2000?
Ensure brevity in your answer.  2.3. What is the difference between the Value added (% of GDP) of Euro area in 1998 and the Value added (% of GDP) of Argentina in 2001?
Ensure brevity in your answer.  -2.28. What is the difference between the Value added (% of GDP) of Euro area in 1998 and the Value added (% of GDP) of Belize in 2001?
Your answer should be very brief. -13.18. What is the difference between the Value added (% of GDP) in Euro area in 1998 and the Value added (% of GDP) in Bolivia in 2001?
Provide a succinct answer. -12.61. What is the difference between the Value added (% of GDP) of Argentina in 1998 and the Value added (% of GDP) of Belize in 2001?
Offer a very short reply. -10.09. What is the difference between the Value added (% of GDP) of Argentina in 1998 and the Value added (% of GDP) of Bolivia in 2001?
Offer a terse response. -9.51. What is the difference between the Value added (% of GDP) in Belize in 1998 and the Value added (% of GDP) in Bolivia in 2001?
Make the answer very short. 2.09. What is the difference between the Value added (% of GDP) of Euro area in 1999 and the Value added (% of GDP) of Argentina in 2000?
Your answer should be compact. -2.59. What is the difference between the Value added (% of GDP) of Euro area in 1999 and the Value added (% of GDP) of Belize in 2000?
Your answer should be very brief. -14.9. What is the difference between the Value added (% of GDP) in Euro area in 1999 and the Value added (% of GDP) in Bolivia in 2000?
Ensure brevity in your answer.  -12.54. What is the difference between the Value added (% of GDP) in Argentina in 1999 and the Value added (% of GDP) in Belize in 2000?
Offer a very short reply. -12.55. What is the difference between the Value added (% of GDP) of Argentina in 1999 and the Value added (% of GDP) of Bolivia in 2000?
Offer a terse response. -10.19. What is the difference between the Value added (% of GDP) in Belize in 1999 and the Value added (% of GDP) in Bolivia in 2000?
Offer a terse response. 2.83. What is the difference between the Value added (% of GDP) of Euro area in 1999 and the Value added (% of GDP) of Argentina in 2001?
Ensure brevity in your answer.  -2.43. What is the difference between the Value added (% of GDP) in Euro area in 1999 and the Value added (% of GDP) in Belize in 2001?
Provide a succinct answer. -13.32. What is the difference between the Value added (% of GDP) of Euro area in 1999 and the Value added (% of GDP) of Bolivia in 2001?
Make the answer very short. -12.75. What is the difference between the Value added (% of GDP) of Argentina in 1999 and the Value added (% of GDP) of Belize in 2001?
Your answer should be very brief. -10.97. What is the difference between the Value added (% of GDP) in Belize in 1999 and the Value added (% of GDP) in Bolivia in 2001?
Make the answer very short. 2.63. What is the difference between the Value added (% of GDP) in Euro area in 2000 and the Value added (% of GDP) in Argentina in 2001?
Keep it short and to the point. -2.51. What is the difference between the Value added (% of GDP) of Euro area in 2000 and the Value added (% of GDP) of Belize in 2001?
Your answer should be very brief. -13.4. What is the difference between the Value added (% of GDP) of Euro area in 2000 and the Value added (% of GDP) of Bolivia in 2001?
Make the answer very short. -12.83. What is the difference between the Value added (% of GDP) of Argentina in 2000 and the Value added (% of GDP) of Belize in 2001?
Provide a short and direct response. -10.74. What is the difference between the Value added (% of GDP) in Argentina in 2000 and the Value added (% of GDP) in Bolivia in 2001?
Make the answer very short. -10.16. What is the difference between the Value added (% of GDP) in Belize in 2000 and the Value added (% of GDP) in Bolivia in 2001?
Offer a very short reply. 2.15. What is the average Value added (% of GDP) in Euro area per year?
Offer a terse response. 2.57. What is the average Value added (% of GDP) in Argentina per year?
Give a very brief answer. 5.44. What is the average Value added (% of GDP) in Belize per year?
Ensure brevity in your answer.  17.55. What is the average Value added (% of GDP) of Bolivia per year?
Make the answer very short. 15.95. In the year 1994, what is the difference between the Value added (% of GDP) of Euro area and Value added (% of GDP) of Argentina?
Your response must be concise. -3.17. In the year 1994, what is the difference between the Value added (% of GDP) of Euro area and Value added (% of GDP) of Belize?
Provide a short and direct response. -15.07. In the year 1994, what is the difference between the Value added (% of GDP) of Euro area and Value added (% of GDP) of Bolivia?
Keep it short and to the point. -14.77. In the year 1994, what is the difference between the Value added (% of GDP) of Argentina and Value added (% of GDP) of Belize?
Provide a short and direct response. -11.91. In the year 1994, what is the difference between the Value added (% of GDP) in Argentina and Value added (% of GDP) in Bolivia?
Keep it short and to the point. -11.6. In the year 1994, what is the difference between the Value added (% of GDP) in Belize and Value added (% of GDP) in Bolivia?
Your answer should be very brief. 0.3. In the year 1995, what is the difference between the Value added (% of GDP) of Euro area and Value added (% of GDP) of Argentina?
Offer a terse response. -2.96. In the year 1995, what is the difference between the Value added (% of GDP) of Euro area and Value added (% of GDP) of Belize?
Your answer should be very brief. -15.52. In the year 1995, what is the difference between the Value added (% of GDP) in Euro area and Value added (% of GDP) in Bolivia?
Give a very brief answer. -14.06. In the year 1995, what is the difference between the Value added (% of GDP) of Argentina and Value added (% of GDP) of Belize?
Make the answer very short. -12.56. In the year 1995, what is the difference between the Value added (% of GDP) in Argentina and Value added (% of GDP) in Bolivia?
Your response must be concise. -11.1. In the year 1995, what is the difference between the Value added (% of GDP) in Belize and Value added (% of GDP) in Bolivia?
Your response must be concise. 1.46. In the year 1996, what is the difference between the Value added (% of GDP) in Euro area and Value added (% of GDP) in Argentina?
Offer a terse response. -3.27. In the year 1996, what is the difference between the Value added (% of GDP) of Euro area and Value added (% of GDP) of Belize?
Offer a terse response. -15.53. In the year 1996, what is the difference between the Value added (% of GDP) in Euro area and Value added (% of GDP) in Bolivia?
Your response must be concise. -13.56. In the year 1996, what is the difference between the Value added (% of GDP) of Argentina and Value added (% of GDP) of Belize?
Provide a succinct answer. -12.26. In the year 1996, what is the difference between the Value added (% of GDP) in Argentina and Value added (% of GDP) in Bolivia?
Your response must be concise. -10.3. In the year 1996, what is the difference between the Value added (% of GDP) of Belize and Value added (% of GDP) of Bolivia?
Your answer should be compact. 1.97. In the year 1997, what is the difference between the Value added (% of GDP) of Euro area and Value added (% of GDP) of Argentina?
Make the answer very short. -2.95. In the year 1997, what is the difference between the Value added (% of GDP) in Euro area and Value added (% of GDP) in Belize?
Your answer should be very brief. -15.24. In the year 1997, what is the difference between the Value added (% of GDP) of Euro area and Value added (% of GDP) of Bolivia?
Your response must be concise. -14.52. In the year 1997, what is the difference between the Value added (% of GDP) in Argentina and Value added (% of GDP) in Belize?
Make the answer very short. -12.29. In the year 1997, what is the difference between the Value added (% of GDP) of Argentina and Value added (% of GDP) of Bolivia?
Make the answer very short. -11.57. In the year 1997, what is the difference between the Value added (% of GDP) in Belize and Value added (% of GDP) in Bolivia?
Your answer should be very brief. 0.73. In the year 1998, what is the difference between the Value added (% of GDP) of Euro area and Value added (% of GDP) of Argentina?
Make the answer very short. -3.09. In the year 1998, what is the difference between the Value added (% of GDP) in Euro area and Value added (% of GDP) in Belize?
Provide a short and direct response. -14.7. In the year 1998, what is the difference between the Value added (% of GDP) in Euro area and Value added (% of GDP) in Bolivia?
Provide a short and direct response. -12.06. In the year 1998, what is the difference between the Value added (% of GDP) of Argentina and Value added (% of GDP) of Belize?
Keep it short and to the point. -11.6. In the year 1998, what is the difference between the Value added (% of GDP) of Argentina and Value added (% of GDP) of Bolivia?
Make the answer very short. -8.97. In the year 1998, what is the difference between the Value added (% of GDP) of Belize and Value added (% of GDP) of Bolivia?
Your response must be concise. 2.63. In the year 1999, what is the difference between the Value added (% of GDP) in Euro area and Value added (% of GDP) in Argentina?
Give a very brief answer. -2.35. In the year 1999, what is the difference between the Value added (% of GDP) of Euro area and Value added (% of GDP) of Belize?
Provide a succinct answer. -15.38. In the year 1999, what is the difference between the Value added (% of GDP) of Euro area and Value added (% of GDP) of Bolivia?
Ensure brevity in your answer.  -12.64. In the year 1999, what is the difference between the Value added (% of GDP) of Argentina and Value added (% of GDP) of Belize?
Keep it short and to the point. -13.03. In the year 1999, what is the difference between the Value added (% of GDP) of Argentina and Value added (% of GDP) of Bolivia?
Ensure brevity in your answer.  -10.29. In the year 1999, what is the difference between the Value added (% of GDP) in Belize and Value added (% of GDP) in Bolivia?
Provide a short and direct response. 2.74. In the year 2000, what is the difference between the Value added (% of GDP) in Euro area and Value added (% of GDP) in Argentina?
Your response must be concise. -2.67. In the year 2000, what is the difference between the Value added (% of GDP) in Euro area and Value added (% of GDP) in Belize?
Provide a short and direct response. -14.98. In the year 2000, what is the difference between the Value added (% of GDP) of Euro area and Value added (% of GDP) of Bolivia?
Ensure brevity in your answer.  -12.62. In the year 2000, what is the difference between the Value added (% of GDP) of Argentina and Value added (% of GDP) of Belize?
Provide a short and direct response. -12.32. In the year 2000, what is the difference between the Value added (% of GDP) in Argentina and Value added (% of GDP) in Bolivia?
Provide a short and direct response. -9.95. In the year 2000, what is the difference between the Value added (% of GDP) of Belize and Value added (% of GDP) of Bolivia?
Offer a terse response. 2.36. In the year 2001, what is the difference between the Value added (% of GDP) of Euro area and Value added (% of GDP) of Argentina?
Make the answer very short. -2.54. In the year 2001, what is the difference between the Value added (% of GDP) of Euro area and Value added (% of GDP) of Belize?
Your answer should be compact. -13.43. In the year 2001, what is the difference between the Value added (% of GDP) in Euro area and Value added (% of GDP) in Bolivia?
Offer a very short reply. -12.86. In the year 2001, what is the difference between the Value added (% of GDP) of Argentina and Value added (% of GDP) of Belize?
Provide a succinct answer. -10.9. In the year 2001, what is the difference between the Value added (% of GDP) of Argentina and Value added (% of GDP) of Bolivia?
Offer a very short reply. -10.32. In the year 2001, what is the difference between the Value added (% of GDP) of Belize and Value added (% of GDP) of Bolivia?
Offer a terse response. 0.57. What is the ratio of the Value added (% of GDP) in Euro area in 1994 to that in 1995?
Provide a short and direct response. 0.83. What is the ratio of the Value added (% of GDP) of Argentina in 1994 to that in 1995?
Give a very brief answer. 0.95. What is the ratio of the Value added (% of GDP) of Belize in 1994 to that in 1995?
Give a very brief answer. 0.95. What is the ratio of the Value added (% of GDP) in Bolivia in 1994 to that in 1995?
Give a very brief answer. 1.01. What is the ratio of the Value added (% of GDP) of Euro area in 1994 to that in 1996?
Provide a succinct answer. 0.83. What is the ratio of the Value added (% of GDP) of Argentina in 1994 to that in 1996?
Offer a very short reply. 0.91. What is the ratio of the Value added (% of GDP) in Belize in 1994 to that in 1996?
Offer a very short reply. 0.95. What is the ratio of the Value added (% of GDP) of Bolivia in 1994 to that in 1996?
Offer a very short reply. 1.04. What is the ratio of the Value added (% of GDP) of Euro area in 1994 to that in 1997?
Keep it short and to the point. 0.86. What is the ratio of the Value added (% of GDP) of Argentina in 1994 to that in 1997?
Provide a short and direct response. 0.97. What is the ratio of the Value added (% of GDP) in Belize in 1994 to that in 1997?
Offer a very short reply. 0.97. What is the ratio of the Value added (% of GDP) in Bolivia in 1994 to that in 1997?
Your answer should be very brief. 0.99. What is the ratio of the Value added (% of GDP) in Euro area in 1994 to that in 1998?
Provide a short and direct response. 0.9. What is the ratio of the Value added (% of GDP) of Argentina in 1994 to that in 1998?
Your answer should be compact. 0.97. What is the ratio of the Value added (% of GDP) in Euro area in 1994 to that in 1999?
Ensure brevity in your answer.  0.95. What is the ratio of the Value added (% of GDP) of Argentina in 1994 to that in 1999?
Your response must be concise. 1.15. What is the ratio of the Value added (% of GDP) of Belize in 1994 to that in 1999?
Give a very brief answer. 0.98. What is the ratio of the Value added (% of GDP) of Bolivia in 1994 to that in 1999?
Provide a succinct answer. 1.13. What is the ratio of the Value added (% of GDP) in Euro area in 1994 to that in 2000?
Keep it short and to the point. 0.98. What is the ratio of the Value added (% of GDP) of Argentina in 1994 to that in 2000?
Give a very brief answer. 1.09. What is the ratio of the Value added (% of GDP) in Belize in 1994 to that in 2000?
Give a very brief answer. 1. What is the ratio of the Value added (% of GDP) in Bolivia in 1994 to that in 2000?
Ensure brevity in your answer.  1.14. What is the ratio of the Value added (% of GDP) of Argentina in 1994 to that in 2001?
Offer a terse response. 1.13. What is the ratio of the Value added (% of GDP) of Belize in 1994 to that in 2001?
Make the answer very short. 1.1. What is the ratio of the Value added (% of GDP) of Bolivia in 1994 to that in 2001?
Offer a terse response. 1.12. What is the ratio of the Value added (% of GDP) of Euro area in 1995 to that in 1996?
Ensure brevity in your answer.  1. What is the ratio of the Value added (% of GDP) in Argentina in 1995 to that in 1996?
Your response must be concise. 0.95. What is the ratio of the Value added (% of GDP) in Belize in 1995 to that in 1996?
Make the answer very short. 1. What is the ratio of the Value added (% of GDP) in Bolivia in 1995 to that in 1996?
Offer a terse response. 1.03. What is the ratio of the Value added (% of GDP) of Euro area in 1995 to that in 1997?
Ensure brevity in your answer.  1.04. What is the ratio of the Value added (% of GDP) in Bolivia in 1995 to that in 1997?
Offer a terse response. 0.98. What is the ratio of the Value added (% of GDP) in Euro area in 1995 to that in 1998?
Make the answer very short. 1.08. What is the ratio of the Value added (% of GDP) of Argentina in 1995 to that in 1998?
Ensure brevity in your answer.  1.01. What is the ratio of the Value added (% of GDP) of Belize in 1995 to that in 1998?
Make the answer very short. 1.06. What is the ratio of the Value added (% of GDP) in Bolivia in 1995 to that in 1998?
Your answer should be compact. 1.15. What is the ratio of the Value added (% of GDP) of Euro area in 1995 to that in 1999?
Offer a very short reply. 1.14. What is the ratio of the Value added (% of GDP) in Argentina in 1995 to that in 1999?
Provide a short and direct response. 1.2. What is the ratio of the Value added (% of GDP) of Belize in 1995 to that in 1999?
Provide a short and direct response. 1.03. What is the ratio of the Value added (% of GDP) in Bolivia in 1995 to that in 1999?
Offer a terse response. 1.12. What is the ratio of the Value added (% of GDP) in Euro area in 1995 to that in 2000?
Give a very brief answer. 1.18. What is the ratio of the Value added (% of GDP) of Argentina in 1995 to that in 2000?
Provide a succinct answer. 1.15. What is the ratio of the Value added (% of GDP) in Belize in 1995 to that in 2000?
Provide a short and direct response. 1.06. What is the ratio of the Value added (% of GDP) in Euro area in 1995 to that in 2001?
Your response must be concise. 1.2. What is the ratio of the Value added (% of GDP) of Argentina in 1995 to that in 2001?
Make the answer very short. 1.18. What is the ratio of the Value added (% of GDP) in Belize in 1995 to that in 2001?
Keep it short and to the point. 1.16. What is the ratio of the Value added (% of GDP) in Bolivia in 1995 to that in 2001?
Ensure brevity in your answer.  1.11. What is the ratio of the Value added (% of GDP) of Euro area in 1996 to that in 1997?
Give a very brief answer. 1.03. What is the ratio of the Value added (% of GDP) of Argentina in 1996 to that in 1997?
Provide a short and direct response. 1.07. What is the ratio of the Value added (% of GDP) of Belize in 1996 to that in 1997?
Give a very brief answer. 1.02. What is the ratio of the Value added (% of GDP) of Bolivia in 1996 to that in 1997?
Make the answer very short. 0.95. What is the ratio of the Value added (% of GDP) of Euro area in 1996 to that in 1998?
Your answer should be very brief. 1.08. What is the ratio of the Value added (% of GDP) of Argentina in 1996 to that in 1998?
Give a very brief answer. 1.07. What is the ratio of the Value added (% of GDP) of Belize in 1996 to that in 1998?
Provide a succinct answer. 1.06. What is the ratio of the Value added (% of GDP) in Bolivia in 1996 to that in 1998?
Keep it short and to the point. 1.12. What is the ratio of the Value added (% of GDP) in Euro area in 1996 to that in 1999?
Offer a terse response. 1.14. What is the ratio of the Value added (% of GDP) in Argentina in 1996 to that in 1999?
Give a very brief answer. 1.26. What is the ratio of the Value added (% of GDP) of Belize in 1996 to that in 1999?
Make the answer very short. 1.03. What is the ratio of the Value added (% of GDP) in Bolivia in 1996 to that in 1999?
Keep it short and to the point. 1.08. What is the ratio of the Value added (% of GDP) in Euro area in 1996 to that in 2000?
Offer a very short reply. 1.18. What is the ratio of the Value added (% of GDP) of Argentina in 1996 to that in 2000?
Your response must be concise. 1.2. What is the ratio of the Value added (% of GDP) in Belize in 1996 to that in 2000?
Provide a succinct answer. 1.06. What is the ratio of the Value added (% of GDP) of Bolivia in 1996 to that in 2000?
Provide a short and direct response. 1.09. What is the ratio of the Value added (% of GDP) of Euro area in 1996 to that in 2001?
Keep it short and to the point. 1.2. What is the ratio of the Value added (% of GDP) in Argentina in 1996 to that in 2001?
Offer a terse response. 1.24. What is the ratio of the Value added (% of GDP) in Belize in 1996 to that in 2001?
Offer a very short reply. 1.16. What is the ratio of the Value added (% of GDP) of Bolivia in 1996 to that in 2001?
Offer a terse response. 1.08. What is the ratio of the Value added (% of GDP) in Euro area in 1997 to that in 1998?
Ensure brevity in your answer.  1.04. What is the ratio of the Value added (% of GDP) of Belize in 1997 to that in 1998?
Keep it short and to the point. 1.04. What is the ratio of the Value added (% of GDP) of Bolivia in 1997 to that in 1998?
Your answer should be compact. 1.18. What is the ratio of the Value added (% of GDP) of Euro area in 1997 to that in 1999?
Your answer should be very brief. 1.1. What is the ratio of the Value added (% of GDP) in Argentina in 1997 to that in 1999?
Offer a very short reply. 1.18. What is the ratio of the Value added (% of GDP) of Belize in 1997 to that in 1999?
Offer a terse response. 1.01. What is the ratio of the Value added (% of GDP) of Bolivia in 1997 to that in 1999?
Offer a terse response. 1.14. What is the ratio of the Value added (% of GDP) of Euro area in 1997 to that in 2000?
Ensure brevity in your answer.  1.14. What is the ratio of the Value added (% of GDP) in Argentina in 1997 to that in 2000?
Offer a terse response. 1.12. What is the ratio of the Value added (% of GDP) of Belize in 1997 to that in 2000?
Offer a terse response. 1.03. What is the ratio of the Value added (% of GDP) in Bolivia in 1997 to that in 2000?
Make the answer very short. 1.15. What is the ratio of the Value added (% of GDP) in Euro area in 1997 to that in 2001?
Ensure brevity in your answer.  1.16. What is the ratio of the Value added (% of GDP) in Argentina in 1997 to that in 2001?
Provide a succinct answer. 1.16. What is the ratio of the Value added (% of GDP) of Belize in 1997 to that in 2001?
Make the answer very short. 1.14. What is the ratio of the Value added (% of GDP) in Bolivia in 1997 to that in 2001?
Keep it short and to the point. 1.13. What is the ratio of the Value added (% of GDP) in Euro area in 1998 to that in 1999?
Keep it short and to the point. 1.06. What is the ratio of the Value added (% of GDP) in Argentina in 1998 to that in 1999?
Ensure brevity in your answer.  1.18. What is the ratio of the Value added (% of GDP) of Belize in 1998 to that in 1999?
Give a very brief answer. 0.97. What is the ratio of the Value added (% of GDP) of Bolivia in 1998 to that in 1999?
Give a very brief answer. 0.97. What is the ratio of the Value added (% of GDP) of Euro area in 1998 to that in 2000?
Your answer should be very brief. 1.09. What is the ratio of the Value added (% of GDP) of Argentina in 1998 to that in 2000?
Keep it short and to the point. 1.13. What is the ratio of the Value added (% of GDP) in Bolivia in 1998 to that in 2000?
Your response must be concise. 0.98. What is the ratio of the Value added (% of GDP) of Euro area in 1998 to that in 2001?
Your response must be concise. 1.11. What is the ratio of the Value added (% of GDP) of Argentina in 1998 to that in 2001?
Ensure brevity in your answer.  1.17. What is the ratio of the Value added (% of GDP) of Belize in 1998 to that in 2001?
Offer a terse response. 1.1. What is the ratio of the Value added (% of GDP) of Bolivia in 1998 to that in 2001?
Provide a short and direct response. 0.96. What is the ratio of the Value added (% of GDP) of Euro area in 1999 to that in 2000?
Give a very brief answer. 1.03. What is the ratio of the Value added (% of GDP) of Argentina in 1999 to that in 2000?
Provide a short and direct response. 0.95. What is the ratio of the Value added (% of GDP) in Belize in 1999 to that in 2000?
Your answer should be compact. 1.03. What is the ratio of the Value added (% of GDP) in Bolivia in 1999 to that in 2000?
Provide a short and direct response. 1.01. What is the ratio of the Value added (% of GDP) in Euro area in 1999 to that in 2001?
Give a very brief answer. 1.05. What is the ratio of the Value added (% of GDP) of Argentina in 1999 to that in 2001?
Offer a very short reply. 0.98. What is the ratio of the Value added (% of GDP) in Belize in 1999 to that in 2001?
Offer a very short reply. 1.13. What is the ratio of the Value added (% of GDP) of Euro area in 2000 to that in 2001?
Make the answer very short. 1.01. What is the ratio of the Value added (% of GDP) in Argentina in 2000 to that in 2001?
Offer a very short reply. 1.03. What is the ratio of the Value added (% of GDP) of Belize in 2000 to that in 2001?
Your response must be concise. 1.1. What is the ratio of the Value added (% of GDP) of Bolivia in 2000 to that in 2001?
Give a very brief answer. 0.99. What is the difference between the highest and the second highest Value added (% of GDP) in Euro area?
Your response must be concise. 0.01. What is the difference between the highest and the second highest Value added (% of GDP) in Argentina?
Your answer should be very brief. 0.29. What is the difference between the highest and the second highest Value added (% of GDP) of Belize?
Provide a succinct answer. 0. What is the difference between the highest and the second highest Value added (% of GDP) of Bolivia?
Make the answer very short. 0.13. What is the difference between the highest and the lowest Value added (% of GDP) in Euro area?
Keep it short and to the point. 0.47. What is the difference between the highest and the lowest Value added (% of GDP) of Argentina?
Make the answer very short. 1.27. What is the difference between the highest and the lowest Value added (% of GDP) of Belize?
Offer a terse response. 2.56. What is the difference between the highest and the lowest Value added (% of GDP) in Bolivia?
Provide a succinct answer. 2.57. 